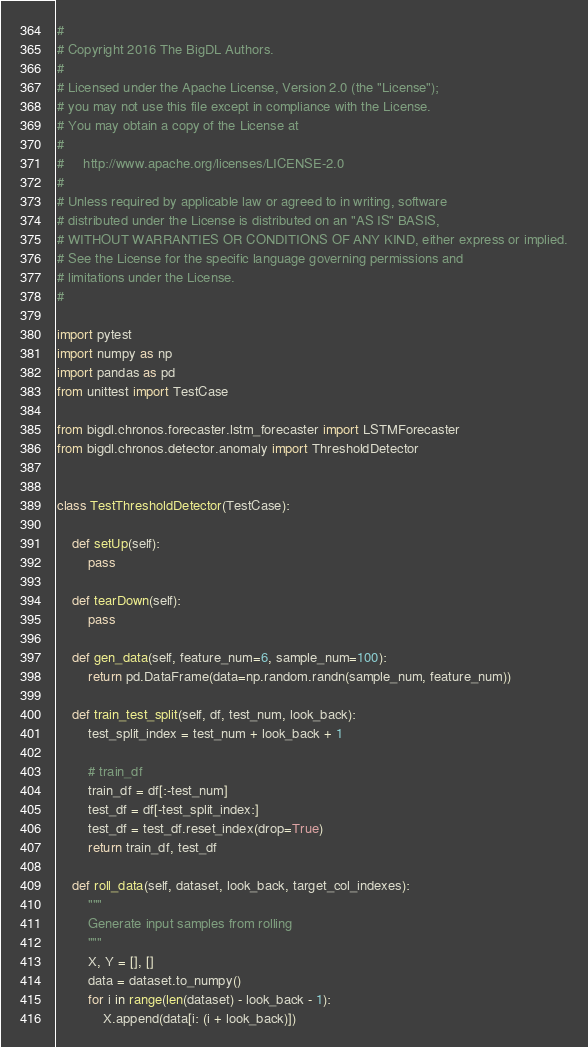Convert code to text. <code><loc_0><loc_0><loc_500><loc_500><_Python_>#
# Copyright 2016 The BigDL Authors.
#
# Licensed under the Apache License, Version 2.0 (the "License");
# you may not use this file except in compliance with the License.
# You may obtain a copy of the License at
#
#     http://www.apache.org/licenses/LICENSE-2.0
#
# Unless required by applicable law or agreed to in writing, software
# distributed under the License is distributed on an "AS IS" BASIS,
# WITHOUT WARRANTIES OR CONDITIONS OF ANY KIND, either express or implied.
# See the License for the specific language governing permissions and
# limitations under the License.
#

import pytest
import numpy as np
import pandas as pd
from unittest import TestCase

from bigdl.chronos.forecaster.lstm_forecaster import LSTMForecaster
from bigdl.chronos.detector.anomaly import ThresholdDetector


class TestThresholdDetector(TestCase):

    def setUp(self):
        pass

    def tearDown(self):
        pass

    def gen_data(self, feature_num=6, sample_num=100):
        return pd.DataFrame(data=np.random.randn(sample_num, feature_num))

    def train_test_split(self, df, test_num, look_back):
        test_split_index = test_num + look_back + 1

        # train_df
        train_df = df[:-test_num]
        test_df = df[-test_split_index:]
        test_df = test_df.reset_index(drop=True)
        return train_df, test_df

    def roll_data(self, dataset, look_back, target_col_indexes):
        """
        Generate input samples from rolling
        """
        X, Y = [], []
        data = dataset.to_numpy()
        for i in range(len(dataset) - look_back - 1):
            X.append(data[i: (i + look_back)])</code> 